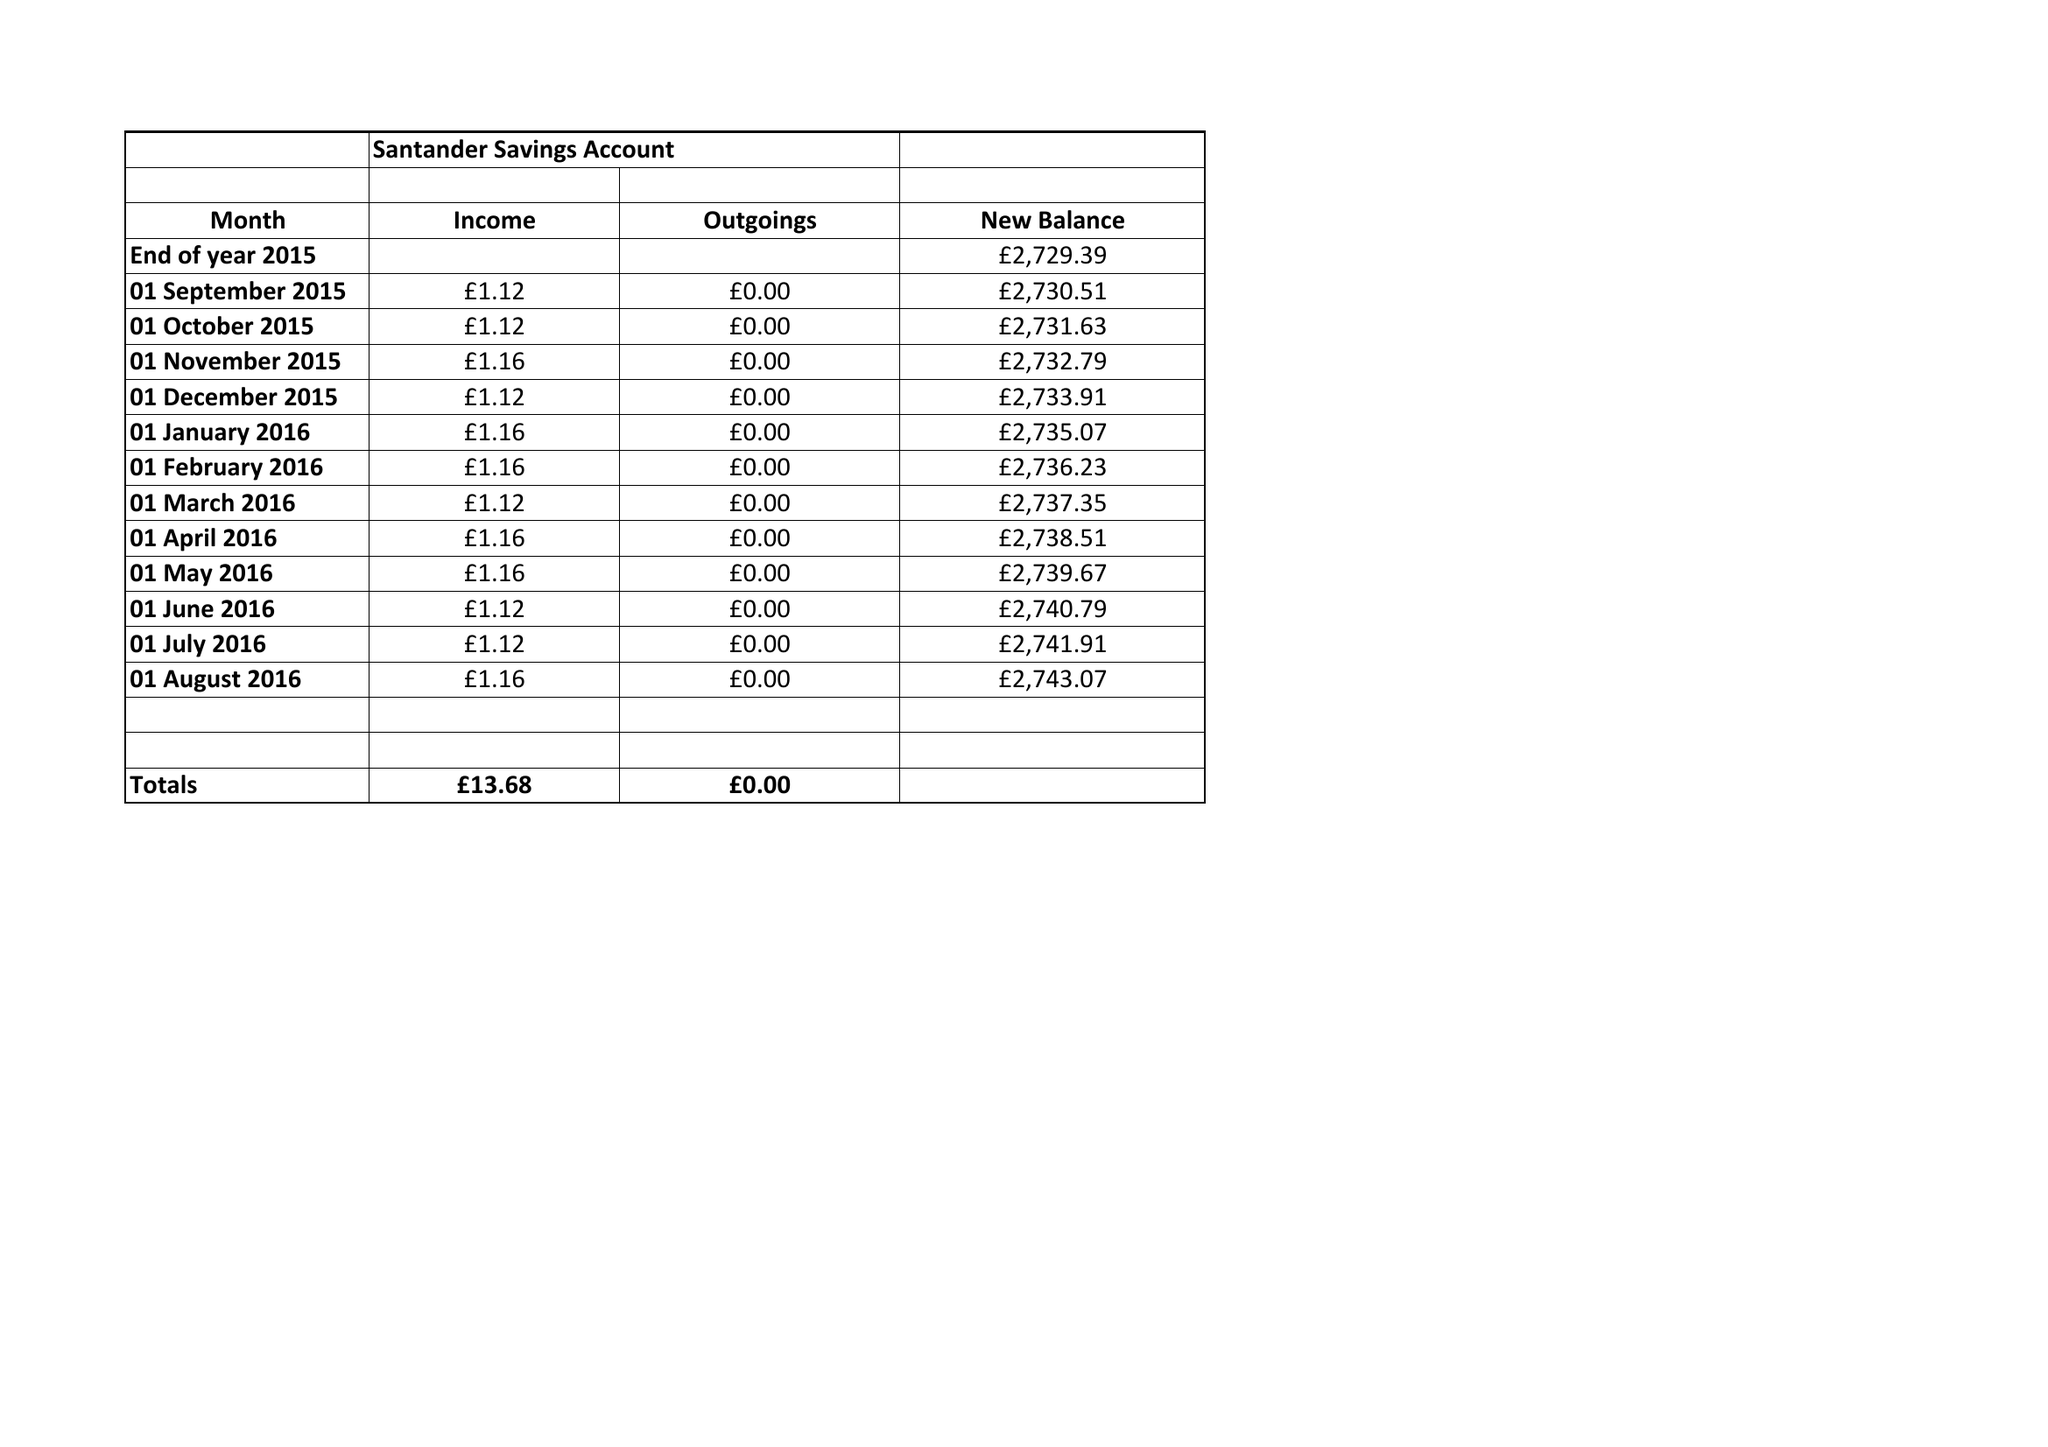What is the value for the charity_number?
Answer the question using a single word or phrase. None 